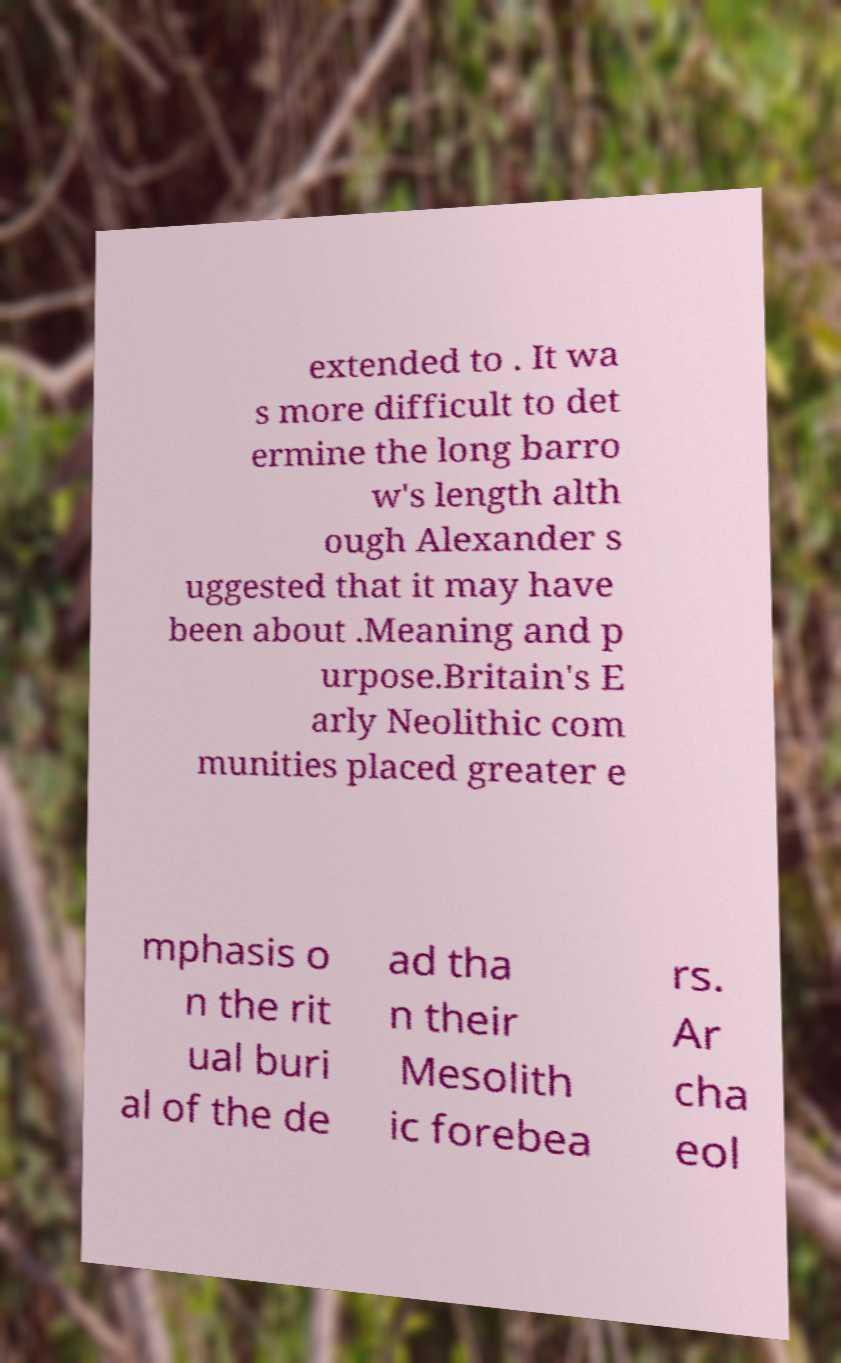I need the written content from this picture converted into text. Can you do that? extended to . It wa s more difficult to det ermine the long barro w's length alth ough Alexander s uggested that it may have been about .Meaning and p urpose.Britain's E arly Neolithic com munities placed greater e mphasis o n the rit ual buri al of the de ad tha n their Mesolith ic forebea rs. Ar cha eol 